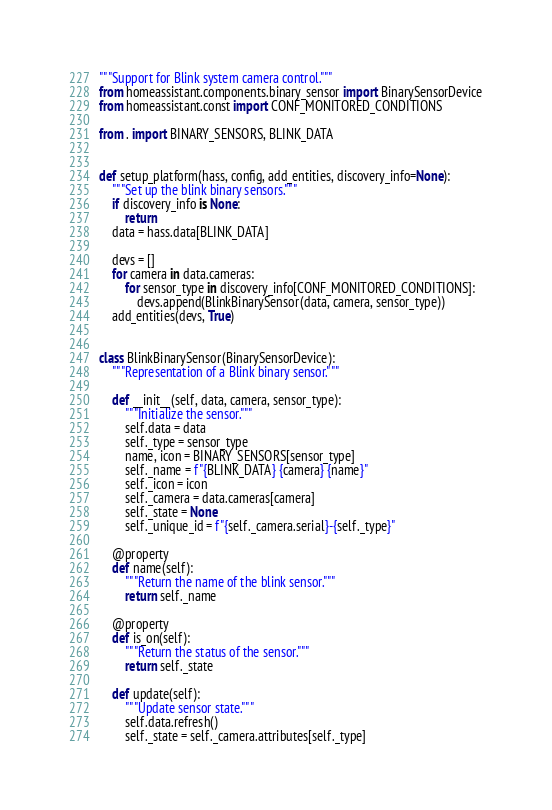Convert code to text. <code><loc_0><loc_0><loc_500><loc_500><_Python_>"""Support for Blink system camera control."""
from homeassistant.components.binary_sensor import BinarySensorDevice
from homeassistant.const import CONF_MONITORED_CONDITIONS

from . import BINARY_SENSORS, BLINK_DATA


def setup_platform(hass, config, add_entities, discovery_info=None):
    """Set up the blink binary sensors."""
    if discovery_info is None:
        return
    data = hass.data[BLINK_DATA]

    devs = []
    for camera in data.cameras:
        for sensor_type in discovery_info[CONF_MONITORED_CONDITIONS]:
            devs.append(BlinkBinarySensor(data, camera, sensor_type))
    add_entities(devs, True)


class BlinkBinarySensor(BinarySensorDevice):
    """Representation of a Blink binary sensor."""

    def __init__(self, data, camera, sensor_type):
        """Initialize the sensor."""
        self.data = data
        self._type = sensor_type
        name, icon = BINARY_SENSORS[sensor_type]
        self._name = f"{BLINK_DATA} {camera} {name}"
        self._icon = icon
        self._camera = data.cameras[camera]
        self._state = None
        self._unique_id = f"{self._camera.serial}-{self._type}"

    @property
    def name(self):
        """Return the name of the blink sensor."""
        return self._name

    @property
    def is_on(self):
        """Return the status of the sensor."""
        return self._state

    def update(self):
        """Update sensor state."""
        self.data.refresh()
        self._state = self._camera.attributes[self._type]
</code> 